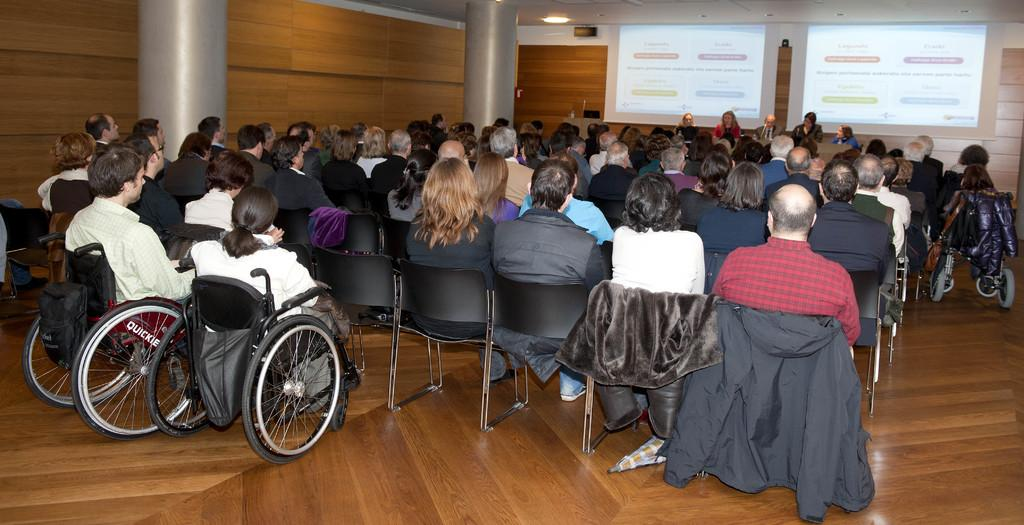What are the people in the image doing? The people in the image are sitting on chairs. What else can be seen in the image besides the people? Clothes and the floor are visible in the image. What architectural features can be seen in the background of the image? There are pillars and a wall in the background of the image. What other objects can be seen in the background of the image? There is a light and screens present in the background of the image. What type of jewel is hanging from the kite in the image? There is no kite or jewel present in the image. How many spoons are visible in the image? There is no mention of spoons in the provided facts, so we cannot determine how many, if any, are visible in the image. 